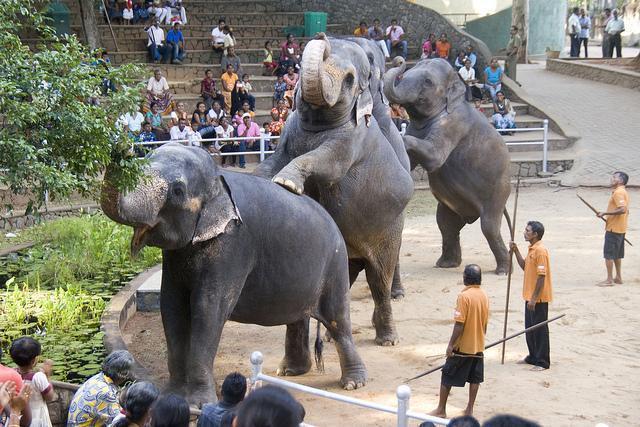What animals might be found in the pond here?
From the following set of four choices, select the accurate answer to respond to the question.
Options: Cats, dogs, fish, elephants. Fish. 